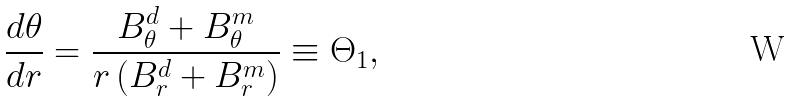Convert formula to latex. <formula><loc_0><loc_0><loc_500><loc_500>\frac { d \theta } { d r } = \frac { B _ { \theta } ^ { d } + B _ { \theta } ^ { m } } { r \left ( B _ { r } ^ { d } + B _ { r } ^ { m } \right ) } \equiv \Theta _ { 1 } ,</formula> 